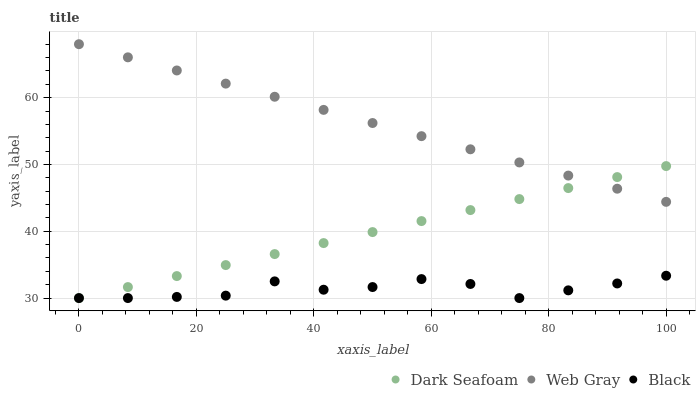Does Black have the minimum area under the curve?
Answer yes or no. Yes. Does Web Gray have the maximum area under the curve?
Answer yes or no. Yes. Does Web Gray have the minimum area under the curve?
Answer yes or no. No. Does Black have the maximum area under the curve?
Answer yes or no. No. Is Dark Seafoam the smoothest?
Answer yes or no. Yes. Is Black the roughest?
Answer yes or no. Yes. Is Web Gray the smoothest?
Answer yes or no. No. Is Web Gray the roughest?
Answer yes or no. No. Does Dark Seafoam have the lowest value?
Answer yes or no. Yes. Does Web Gray have the lowest value?
Answer yes or no. No. Does Web Gray have the highest value?
Answer yes or no. Yes. Does Black have the highest value?
Answer yes or no. No. Is Black less than Web Gray?
Answer yes or no. Yes. Is Web Gray greater than Black?
Answer yes or no. Yes. Does Black intersect Dark Seafoam?
Answer yes or no. Yes. Is Black less than Dark Seafoam?
Answer yes or no. No. Is Black greater than Dark Seafoam?
Answer yes or no. No. Does Black intersect Web Gray?
Answer yes or no. No. 